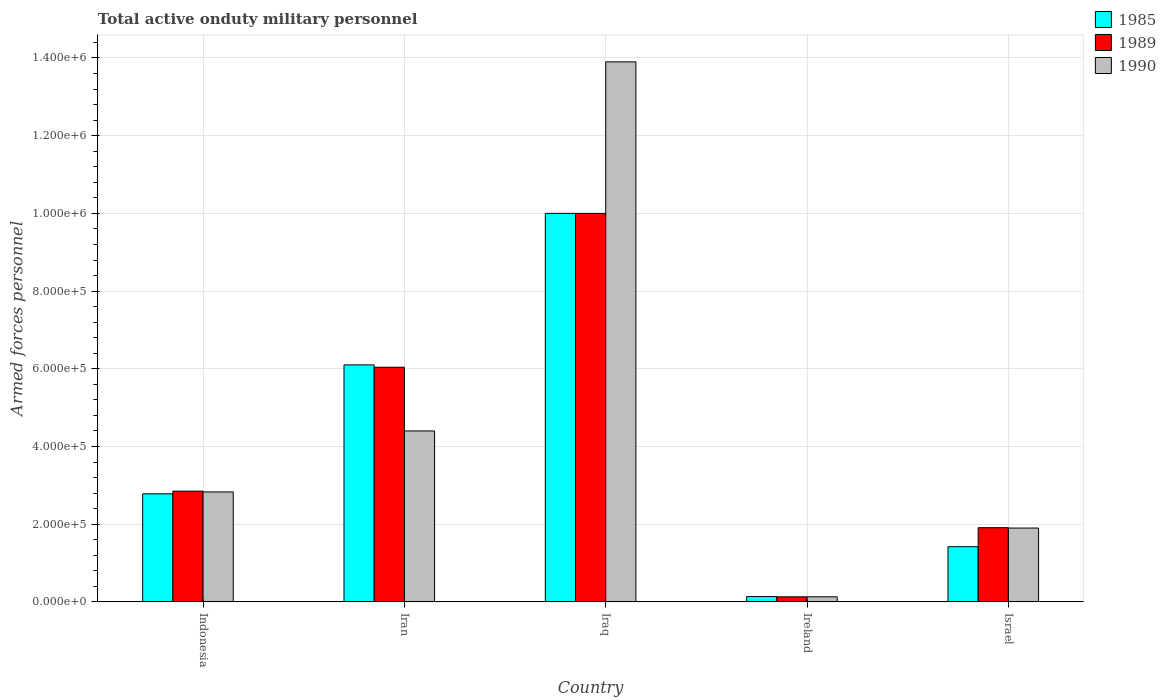How many groups of bars are there?
Provide a short and direct response. 5. Are the number of bars per tick equal to the number of legend labels?
Make the answer very short. Yes. What is the label of the 4th group of bars from the left?
Your answer should be very brief. Ireland. What is the number of armed forces personnel in 1990 in Iraq?
Your answer should be compact. 1.39e+06. Across all countries, what is the minimum number of armed forces personnel in 1990?
Your answer should be compact. 1.30e+04. In which country was the number of armed forces personnel in 1989 maximum?
Your response must be concise. Iraq. In which country was the number of armed forces personnel in 1989 minimum?
Offer a very short reply. Ireland. What is the total number of armed forces personnel in 1990 in the graph?
Give a very brief answer. 2.32e+06. What is the difference between the number of armed forces personnel in 1989 in Iran and that in Ireland?
Give a very brief answer. 5.91e+05. What is the difference between the number of armed forces personnel in 1985 in Iraq and the number of armed forces personnel in 1989 in Ireland?
Offer a very short reply. 9.87e+05. What is the average number of armed forces personnel in 1985 per country?
Offer a terse response. 4.09e+05. What is the ratio of the number of armed forces personnel in 1990 in Indonesia to that in Iran?
Your response must be concise. 0.64. Is the number of armed forces personnel in 1989 in Indonesia less than that in Israel?
Your response must be concise. No. What is the difference between the highest and the second highest number of armed forces personnel in 1985?
Provide a short and direct response. 7.22e+05. What is the difference between the highest and the lowest number of armed forces personnel in 1990?
Your answer should be compact. 1.38e+06. In how many countries, is the number of armed forces personnel in 1989 greater than the average number of armed forces personnel in 1989 taken over all countries?
Ensure brevity in your answer.  2. Is it the case that in every country, the sum of the number of armed forces personnel in 1989 and number of armed forces personnel in 1985 is greater than the number of armed forces personnel in 1990?
Your answer should be very brief. Yes. What is the difference between two consecutive major ticks on the Y-axis?
Offer a very short reply. 2.00e+05. Does the graph contain grids?
Your answer should be compact. Yes. Where does the legend appear in the graph?
Offer a very short reply. Top right. How many legend labels are there?
Provide a succinct answer. 3. What is the title of the graph?
Offer a very short reply. Total active onduty military personnel. Does "2009" appear as one of the legend labels in the graph?
Ensure brevity in your answer.  No. What is the label or title of the X-axis?
Your answer should be very brief. Country. What is the label or title of the Y-axis?
Ensure brevity in your answer.  Armed forces personnel. What is the Armed forces personnel in 1985 in Indonesia?
Your answer should be very brief. 2.78e+05. What is the Armed forces personnel of 1989 in Indonesia?
Your response must be concise. 2.85e+05. What is the Armed forces personnel of 1990 in Indonesia?
Provide a short and direct response. 2.83e+05. What is the Armed forces personnel in 1985 in Iran?
Ensure brevity in your answer.  6.10e+05. What is the Armed forces personnel of 1989 in Iran?
Give a very brief answer. 6.04e+05. What is the Armed forces personnel of 1990 in Iraq?
Make the answer very short. 1.39e+06. What is the Armed forces personnel of 1985 in Ireland?
Provide a succinct answer. 1.37e+04. What is the Armed forces personnel in 1989 in Ireland?
Keep it short and to the point. 1.30e+04. What is the Armed forces personnel of 1990 in Ireland?
Your answer should be compact. 1.30e+04. What is the Armed forces personnel of 1985 in Israel?
Your answer should be compact. 1.42e+05. What is the Armed forces personnel of 1989 in Israel?
Ensure brevity in your answer.  1.91e+05. Across all countries, what is the maximum Armed forces personnel of 1990?
Your response must be concise. 1.39e+06. Across all countries, what is the minimum Armed forces personnel in 1985?
Offer a very short reply. 1.37e+04. Across all countries, what is the minimum Armed forces personnel of 1989?
Your response must be concise. 1.30e+04. Across all countries, what is the minimum Armed forces personnel in 1990?
Offer a very short reply. 1.30e+04. What is the total Armed forces personnel of 1985 in the graph?
Ensure brevity in your answer.  2.04e+06. What is the total Armed forces personnel of 1989 in the graph?
Your response must be concise. 2.09e+06. What is the total Armed forces personnel of 1990 in the graph?
Your answer should be compact. 2.32e+06. What is the difference between the Armed forces personnel in 1985 in Indonesia and that in Iran?
Ensure brevity in your answer.  -3.32e+05. What is the difference between the Armed forces personnel in 1989 in Indonesia and that in Iran?
Offer a terse response. -3.19e+05. What is the difference between the Armed forces personnel of 1990 in Indonesia and that in Iran?
Provide a short and direct response. -1.57e+05. What is the difference between the Armed forces personnel in 1985 in Indonesia and that in Iraq?
Offer a terse response. -7.22e+05. What is the difference between the Armed forces personnel in 1989 in Indonesia and that in Iraq?
Your response must be concise. -7.15e+05. What is the difference between the Armed forces personnel of 1990 in Indonesia and that in Iraq?
Give a very brief answer. -1.11e+06. What is the difference between the Armed forces personnel of 1985 in Indonesia and that in Ireland?
Offer a terse response. 2.64e+05. What is the difference between the Armed forces personnel of 1989 in Indonesia and that in Ireland?
Keep it short and to the point. 2.72e+05. What is the difference between the Armed forces personnel of 1990 in Indonesia and that in Ireland?
Provide a succinct answer. 2.70e+05. What is the difference between the Armed forces personnel of 1985 in Indonesia and that in Israel?
Offer a very short reply. 1.36e+05. What is the difference between the Armed forces personnel of 1989 in Indonesia and that in Israel?
Your response must be concise. 9.40e+04. What is the difference between the Armed forces personnel of 1990 in Indonesia and that in Israel?
Keep it short and to the point. 9.30e+04. What is the difference between the Armed forces personnel in 1985 in Iran and that in Iraq?
Give a very brief answer. -3.90e+05. What is the difference between the Armed forces personnel in 1989 in Iran and that in Iraq?
Make the answer very short. -3.96e+05. What is the difference between the Armed forces personnel in 1990 in Iran and that in Iraq?
Your answer should be very brief. -9.50e+05. What is the difference between the Armed forces personnel of 1985 in Iran and that in Ireland?
Offer a very short reply. 5.96e+05. What is the difference between the Armed forces personnel of 1989 in Iran and that in Ireland?
Ensure brevity in your answer.  5.91e+05. What is the difference between the Armed forces personnel of 1990 in Iran and that in Ireland?
Make the answer very short. 4.27e+05. What is the difference between the Armed forces personnel in 1985 in Iran and that in Israel?
Your answer should be compact. 4.68e+05. What is the difference between the Armed forces personnel of 1989 in Iran and that in Israel?
Your answer should be compact. 4.13e+05. What is the difference between the Armed forces personnel in 1985 in Iraq and that in Ireland?
Ensure brevity in your answer.  9.86e+05. What is the difference between the Armed forces personnel of 1989 in Iraq and that in Ireland?
Give a very brief answer. 9.87e+05. What is the difference between the Armed forces personnel in 1990 in Iraq and that in Ireland?
Offer a very short reply. 1.38e+06. What is the difference between the Armed forces personnel of 1985 in Iraq and that in Israel?
Give a very brief answer. 8.58e+05. What is the difference between the Armed forces personnel in 1989 in Iraq and that in Israel?
Provide a short and direct response. 8.09e+05. What is the difference between the Armed forces personnel in 1990 in Iraq and that in Israel?
Offer a terse response. 1.20e+06. What is the difference between the Armed forces personnel of 1985 in Ireland and that in Israel?
Make the answer very short. -1.28e+05. What is the difference between the Armed forces personnel of 1989 in Ireland and that in Israel?
Your answer should be compact. -1.78e+05. What is the difference between the Armed forces personnel in 1990 in Ireland and that in Israel?
Provide a succinct answer. -1.77e+05. What is the difference between the Armed forces personnel of 1985 in Indonesia and the Armed forces personnel of 1989 in Iran?
Make the answer very short. -3.26e+05. What is the difference between the Armed forces personnel of 1985 in Indonesia and the Armed forces personnel of 1990 in Iran?
Keep it short and to the point. -1.62e+05. What is the difference between the Armed forces personnel of 1989 in Indonesia and the Armed forces personnel of 1990 in Iran?
Provide a short and direct response. -1.55e+05. What is the difference between the Armed forces personnel in 1985 in Indonesia and the Armed forces personnel in 1989 in Iraq?
Keep it short and to the point. -7.22e+05. What is the difference between the Armed forces personnel in 1985 in Indonesia and the Armed forces personnel in 1990 in Iraq?
Provide a succinct answer. -1.11e+06. What is the difference between the Armed forces personnel of 1989 in Indonesia and the Armed forces personnel of 1990 in Iraq?
Your answer should be compact. -1.10e+06. What is the difference between the Armed forces personnel in 1985 in Indonesia and the Armed forces personnel in 1989 in Ireland?
Your answer should be very brief. 2.65e+05. What is the difference between the Armed forces personnel of 1985 in Indonesia and the Armed forces personnel of 1990 in Ireland?
Keep it short and to the point. 2.65e+05. What is the difference between the Armed forces personnel in 1989 in Indonesia and the Armed forces personnel in 1990 in Ireland?
Provide a succinct answer. 2.72e+05. What is the difference between the Armed forces personnel in 1985 in Indonesia and the Armed forces personnel in 1989 in Israel?
Make the answer very short. 8.71e+04. What is the difference between the Armed forces personnel of 1985 in Indonesia and the Armed forces personnel of 1990 in Israel?
Provide a succinct answer. 8.81e+04. What is the difference between the Armed forces personnel of 1989 in Indonesia and the Armed forces personnel of 1990 in Israel?
Offer a terse response. 9.50e+04. What is the difference between the Armed forces personnel in 1985 in Iran and the Armed forces personnel in 1989 in Iraq?
Provide a short and direct response. -3.90e+05. What is the difference between the Armed forces personnel of 1985 in Iran and the Armed forces personnel of 1990 in Iraq?
Your answer should be compact. -7.80e+05. What is the difference between the Armed forces personnel of 1989 in Iran and the Armed forces personnel of 1990 in Iraq?
Your answer should be very brief. -7.86e+05. What is the difference between the Armed forces personnel of 1985 in Iran and the Armed forces personnel of 1989 in Ireland?
Keep it short and to the point. 5.97e+05. What is the difference between the Armed forces personnel of 1985 in Iran and the Armed forces personnel of 1990 in Ireland?
Your response must be concise. 5.97e+05. What is the difference between the Armed forces personnel of 1989 in Iran and the Armed forces personnel of 1990 in Ireland?
Make the answer very short. 5.91e+05. What is the difference between the Armed forces personnel in 1985 in Iran and the Armed forces personnel in 1989 in Israel?
Ensure brevity in your answer.  4.19e+05. What is the difference between the Armed forces personnel of 1985 in Iran and the Armed forces personnel of 1990 in Israel?
Offer a terse response. 4.20e+05. What is the difference between the Armed forces personnel in 1989 in Iran and the Armed forces personnel in 1990 in Israel?
Ensure brevity in your answer.  4.14e+05. What is the difference between the Armed forces personnel of 1985 in Iraq and the Armed forces personnel of 1989 in Ireland?
Keep it short and to the point. 9.87e+05. What is the difference between the Armed forces personnel of 1985 in Iraq and the Armed forces personnel of 1990 in Ireland?
Provide a succinct answer. 9.87e+05. What is the difference between the Armed forces personnel of 1989 in Iraq and the Armed forces personnel of 1990 in Ireland?
Your response must be concise. 9.87e+05. What is the difference between the Armed forces personnel of 1985 in Iraq and the Armed forces personnel of 1989 in Israel?
Your response must be concise. 8.09e+05. What is the difference between the Armed forces personnel in 1985 in Iraq and the Armed forces personnel in 1990 in Israel?
Keep it short and to the point. 8.10e+05. What is the difference between the Armed forces personnel of 1989 in Iraq and the Armed forces personnel of 1990 in Israel?
Make the answer very short. 8.10e+05. What is the difference between the Armed forces personnel of 1985 in Ireland and the Armed forces personnel of 1989 in Israel?
Your answer should be very brief. -1.77e+05. What is the difference between the Armed forces personnel of 1985 in Ireland and the Armed forces personnel of 1990 in Israel?
Ensure brevity in your answer.  -1.76e+05. What is the difference between the Armed forces personnel in 1989 in Ireland and the Armed forces personnel in 1990 in Israel?
Keep it short and to the point. -1.77e+05. What is the average Armed forces personnel of 1985 per country?
Give a very brief answer. 4.09e+05. What is the average Armed forces personnel of 1989 per country?
Your answer should be very brief. 4.19e+05. What is the average Armed forces personnel of 1990 per country?
Offer a very short reply. 4.63e+05. What is the difference between the Armed forces personnel of 1985 and Armed forces personnel of 1989 in Indonesia?
Keep it short and to the point. -6900. What is the difference between the Armed forces personnel of 1985 and Armed forces personnel of 1990 in Indonesia?
Keep it short and to the point. -4900. What is the difference between the Armed forces personnel in 1989 and Armed forces personnel in 1990 in Indonesia?
Make the answer very short. 2000. What is the difference between the Armed forces personnel in 1985 and Armed forces personnel in 1989 in Iran?
Make the answer very short. 6000. What is the difference between the Armed forces personnel of 1985 and Armed forces personnel of 1990 in Iran?
Your answer should be compact. 1.70e+05. What is the difference between the Armed forces personnel of 1989 and Armed forces personnel of 1990 in Iran?
Provide a short and direct response. 1.64e+05. What is the difference between the Armed forces personnel in 1985 and Armed forces personnel in 1989 in Iraq?
Offer a terse response. 0. What is the difference between the Armed forces personnel in 1985 and Armed forces personnel in 1990 in Iraq?
Your response must be concise. -3.90e+05. What is the difference between the Armed forces personnel in 1989 and Armed forces personnel in 1990 in Iraq?
Offer a very short reply. -3.90e+05. What is the difference between the Armed forces personnel in 1985 and Armed forces personnel in 1989 in Ireland?
Offer a terse response. 700. What is the difference between the Armed forces personnel of 1985 and Armed forces personnel of 1990 in Ireland?
Give a very brief answer. 700. What is the difference between the Armed forces personnel in 1985 and Armed forces personnel in 1989 in Israel?
Provide a succinct answer. -4.90e+04. What is the difference between the Armed forces personnel of 1985 and Armed forces personnel of 1990 in Israel?
Your answer should be very brief. -4.80e+04. What is the ratio of the Armed forces personnel in 1985 in Indonesia to that in Iran?
Give a very brief answer. 0.46. What is the ratio of the Armed forces personnel of 1989 in Indonesia to that in Iran?
Provide a short and direct response. 0.47. What is the ratio of the Armed forces personnel in 1990 in Indonesia to that in Iran?
Provide a succinct answer. 0.64. What is the ratio of the Armed forces personnel of 1985 in Indonesia to that in Iraq?
Offer a terse response. 0.28. What is the ratio of the Armed forces personnel in 1989 in Indonesia to that in Iraq?
Provide a succinct answer. 0.28. What is the ratio of the Armed forces personnel in 1990 in Indonesia to that in Iraq?
Offer a very short reply. 0.2. What is the ratio of the Armed forces personnel in 1985 in Indonesia to that in Ireland?
Your answer should be very brief. 20.3. What is the ratio of the Armed forces personnel of 1989 in Indonesia to that in Ireland?
Your answer should be very brief. 21.92. What is the ratio of the Armed forces personnel of 1990 in Indonesia to that in Ireland?
Provide a succinct answer. 21.77. What is the ratio of the Armed forces personnel in 1985 in Indonesia to that in Israel?
Your response must be concise. 1.96. What is the ratio of the Armed forces personnel of 1989 in Indonesia to that in Israel?
Provide a short and direct response. 1.49. What is the ratio of the Armed forces personnel in 1990 in Indonesia to that in Israel?
Provide a succinct answer. 1.49. What is the ratio of the Armed forces personnel in 1985 in Iran to that in Iraq?
Make the answer very short. 0.61. What is the ratio of the Armed forces personnel of 1989 in Iran to that in Iraq?
Keep it short and to the point. 0.6. What is the ratio of the Armed forces personnel of 1990 in Iran to that in Iraq?
Your answer should be compact. 0.32. What is the ratio of the Armed forces personnel of 1985 in Iran to that in Ireland?
Your response must be concise. 44.53. What is the ratio of the Armed forces personnel of 1989 in Iran to that in Ireland?
Provide a short and direct response. 46.46. What is the ratio of the Armed forces personnel in 1990 in Iran to that in Ireland?
Ensure brevity in your answer.  33.85. What is the ratio of the Armed forces personnel in 1985 in Iran to that in Israel?
Your answer should be very brief. 4.3. What is the ratio of the Armed forces personnel of 1989 in Iran to that in Israel?
Provide a succinct answer. 3.16. What is the ratio of the Armed forces personnel in 1990 in Iran to that in Israel?
Provide a succinct answer. 2.32. What is the ratio of the Armed forces personnel in 1985 in Iraq to that in Ireland?
Offer a terse response. 72.99. What is the ratio of the Armed forces personnel of 1989 in Iraq to that in Ireland?
Provide a short and direct response. 76.92. What is the ratio of the Armed forces personnel in 1990 in Iraq to that in Ireland?
Your answer should be compact. 106.92. What is the ratio of the Armed forces personnel in 1985 in Iraq to that in Israel?
Ensure brevity in your answer.  7.04. What is the ratio of the Armed forces personnel of 1989 in Iraq to that in Israel?
Your answer should be compact. 5.24. What is the ratio of the Armed forces personnel in 1990 in Iraq to that in Israel?
Give a very brief answer. 7.32. What is the ratio of the Armed forces personnel of 1985 in Ireland to that in Israel?
Your answer should be compact. 0.1. What is the ratio of the Armed forces personnel in 1989 in Ireland to that in Israel?
Your answer should be very brief. 0.07. What is the ratio of the Armed forces personnel of 1990 in Ireland to that in Israel?
Ensure brevity in your answer.  0.07. What is the difference between the highest and the second highest Armed forces personnel of 1989?
Provide a succinct answer. 3.96e+05. What is the difference between the highest and the second highest Armed forces personnel of 1990?
Your answer should be very brief. 9.50e+05. What is the difference between the highest and the lowest Armed forces personnel in 1985?
Your response must be concise. 9.86e+05. What is the difference between the highest and the lowest Armed forces personnel of 1989?
Provide a succinct answer. 9.87e+05. What is the difference between the highest and the lowest Armed forces personnel of 1990?
Your answer should be compact. 1.38e+06. 